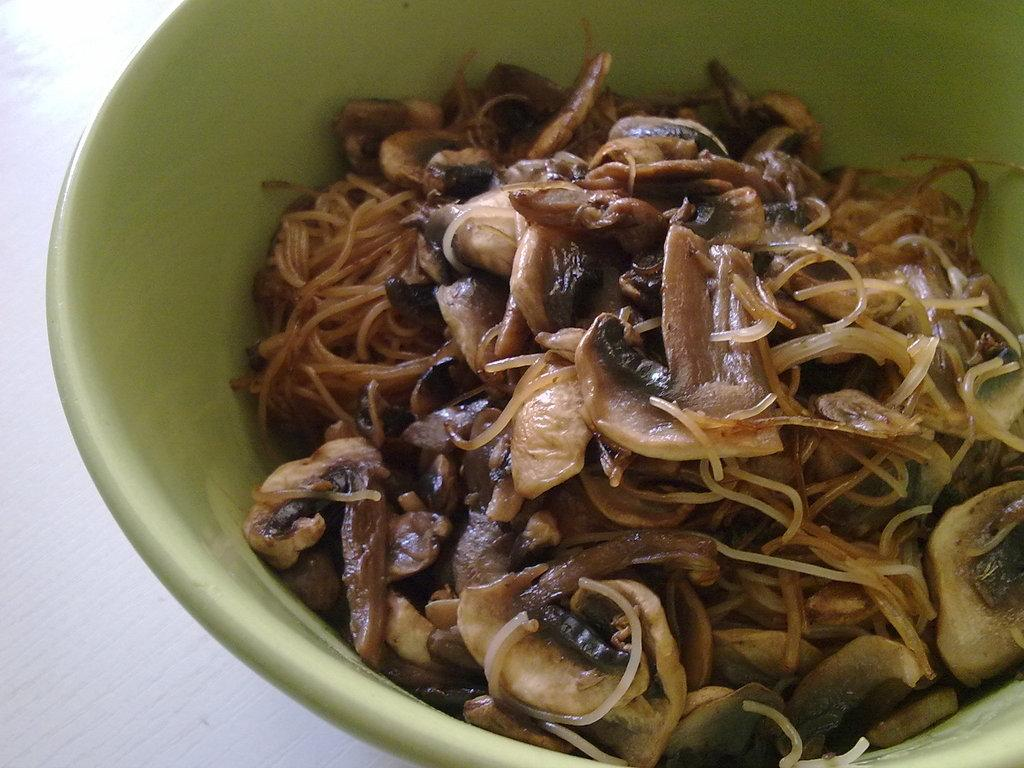What is present in the image? There is a bowl in the image. What is inside the bowl? There is a food item in the bowl. What type of secretary can be seen working in the image? There is no secretary present in the image; it only contains a bowl with a food item. 